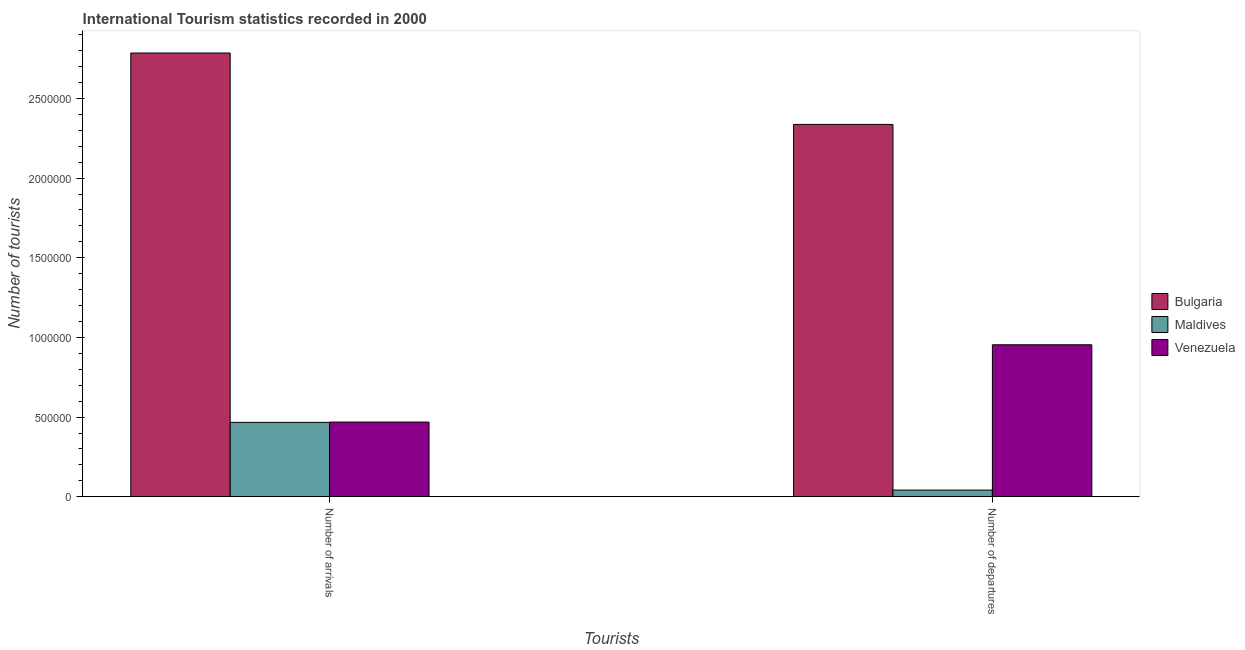How many different coloured bars are there?
Offer a terse response. 3. How many bars are there on the 2nd tick from the right?
Your answer should be very brief. 3. What is the label of the 1st group of bars from the left?
Your answer should be compact. Number of arrivals. What is the number of tourist arrivals in Bulgaria?
Keep it short and to the point. 2.78e+06. Across all countries, what is the maximum number of tourist arrivals?
Keep it short and to the point. 2.78e+06. Across all countries, what is the minimum number of tourist departures?
Ensure brevity in your answer.  4.20e+04. In which country was the number of tourist departures minimum?
Provide a succinct answer. Maldives. What is the total number of tourist departures in the graph?
Keep it short and to the point. 3.33e+06. What is the difference between the number of tourist departures in Maldives and that in Bulgaria?
Your response must be concise. -2.30e+06. What is the difference between the number of tourist departures in Bulgaria and the number of tourist arrivals in Venezuela?
Your response must be concise. 1.87e+06. What is the average number of tourist departures per country?
Ensure brevity in your answer.  1.11e+06. What is the difference between the number of tourist departures and number of tourist arrivals in Bulgaria?
Make the answer very short. -4.48e+05. In how many countries, is the number of tourist arrivals greater than 2000000 ?
Keep it short and to the point. 1. What is the ratio of the number of tourist departures in Maldives to that in Bulgaria?
Offer a terse response. 0.02. Is the number of tourist departures in Venezuela less than that in Bulgaria?
Make the answer very short. Yes. In how many countries, is the number of tourist arrivals greater than the average number of tourist arrivals taken over all countries?
Make the answer very short. 1. What does the 3rd bar from the left in Number of arrivals represents?
Give a very brief answer. Venezuela. What does the 2nd bar from the right in Number of departures represents?
Your answer should be compact. Maldives. How many bars are there?
Keep it short and to the point. 6. Are all the bars in the graph horizontal?
Keep it short and to the point. No. Are the values on the major ticks of Y-axis written in scientific E-notation?
Make the answer very short. No. Does the graph contain any zero values?
Offer a very short reply. No. Where does the legend appear in the graph?
Give a very brief answer. Center right. What is the title of the graph?
Offer a terse response. International Tourism statistics recorded in 2000. Does "Europe(all income levels)" appear as one of the legend labels in the graph?
Give a very brief answer. No. What is the label or title of the X-axis?
Provide a succinct answer. Tourists. What is the label or title of the Y-axis?
Keep it short and to the point. Number of tourists. What is the Number of tourists in Bulgaria in Number of arrivals?
Offer a very short reply. 2.78e+06. What is the Number of tourists of Maldives in Number of arrivals?
Make the answer very short. 4.67e+05. What is the Number of tourists in Venezuela in Number of arrivals?
Your response must be concise. 4.69e+05. What is the Number of tourists of Bulgaria in Number of departures?
Provide a succinct answer. 2.34e+06. What is the Number of tourists in Maldives in Number of departures?
Ensure brevity in your answer.  4.20e+04. What is the Number of tourists of Venezuela in Number of departures?
Make the answer very short. 9.54e+05. Across all Tourists, what is the maximum Number of tourists of Bulgaria?
Provide a succinct answer. 2.78e+06. Across all Tourists, what is the maximum Number of tourists in Maldives?
Offer a terse response. 4.67e+05. Across all Tourists, what is the maximum Number of tourists of Venezuela?
Offer a very short reply. 9.54e+05. Across all Tourists, what is the minimum Number of tourists of Bulgaria?
Ensure brevity in your answer.  2.34e+06. Across all Tourists, what is the minimum Number of tourists of Maldives?
Provide a succinct answer. 4.20e+04. Across all Tourists, what is the minimum Number of tourists in Venezuela?
Offer a terse response. 4.69e+05. What is the total Number of tourists of Bulgaria in the graph?
Make the answer very short. 5.12e+06. What is the total Number of tourists of Maldives in the graph?
Offer a very short reply. 5.09e+05. What is the total Number of tourists of Venezuela in the graph?
Make the answer very short. 1.42e+06. What is the difference between the Number of tourists of Bulgaria in Number of arrivals and that in Number of departures?
Offer a very short reply. 4.48e+05. What is the difference between the Number of tourists in Maldives in Number of arrivals and that in Number of departures?
Provide a succinct answer. 4.25e+05. What is the difference between the Number of tourists in Venezuela in Number of arrivals and that in Number of departures?
Your answer should be very brief. -4.85e+05. What is the difference between the Number of tourists of Bulgaria in Number of arrivals and the Number of tourists of Maldives in Number of departures?
Ensure brevity in your answer.  2.74e+06. What is the difference between the Number of tourists in Bulgaria in Number of arrivals and the Number of tourists in Venezuela in Number of departures?
Keep it short and to the point. 1.83e+06. What is the difference between the Number of tourists in Maldives in Number of arrivals and the Number of tourists in Venezuela in Number of departures?
Offer a very short reply. -4.87e+05. What is the average Number of tourists in Bulgaria per Tourists?
Offer a terse response. 2.56e+06. What is the average Number of tourists of Maldives per Tourists?
Provide a succinct answer. 2.54e+05. What is the average Number of tourists of Venezuela per Tourists?
Offer a terse response. 7.12e+05. What is the difference between the Number of tourists in Bulgaria and Number of tourists in Maldives in Number of arrivals?
Offer a terse response. 2.32e+06. What is the difference between the Number of tourists in Bulgaria and Number of tourists in Venezuela in Number of arrivals?
Keep it short and to the point. 2.32e+06. What is the difference between the Number of tourists of Maldives and Number of tourists of Venezuela in Number of arrivals?
Your answer should be compact. -2000. What is the difference between the Number of tourists of Bulgaria and Number of tourists of Maldives in Number of departures?
Ensure brevity in your answer.  2.30e+06. What is the difference between the Number of tourists in Bulgaria and Number of tourists in Venezuela in Number of departures?
Your response must be concise. 1.38e+06. What is the difference between the Number of tourists of Maldives and Number of tourists of Venezuela in Number of departures?
Your response must be concise. -9.12e+05. What is the ratio of the Number of tourists of Bulgaria in Number of arrivals to that in Number of departures?
Your answer should be compact. 1.19. What is the ratio of the Number of tourists in Maldives in Number of arrivals to that in Number of departures?
Provide a succinct answer. 11.12. What is the ratio of the Number of tourists of Venezuela in Number of arrivals to that in Number of departures?
Your answer should be compact. 0.49. What is the difference between the highest and the second highest Number of tourists in Bulgaria?
Make the answer very short. 4.48e+05. What is the difference between the highest and the second highest Number of tourists in Maldives?
Your response must be concise. 4.25e+05. What is the difference between the highest and the second highest Number of tourists of Venezuela?
Make the answer very short. 4.85e+05. What is the difference between the highest and the lowest Number of tourists in Bulgaria?
Your answer should be very brief. 4.48e+05. What is the difference between the highest and the lowest Number of tourists in Maldives?
Your answer should be compact. 4.25e+05. What is the difference between the highest and the lowest Number of tourists of Venezuela?
Keep it short and to the point. 4.85e+05. 